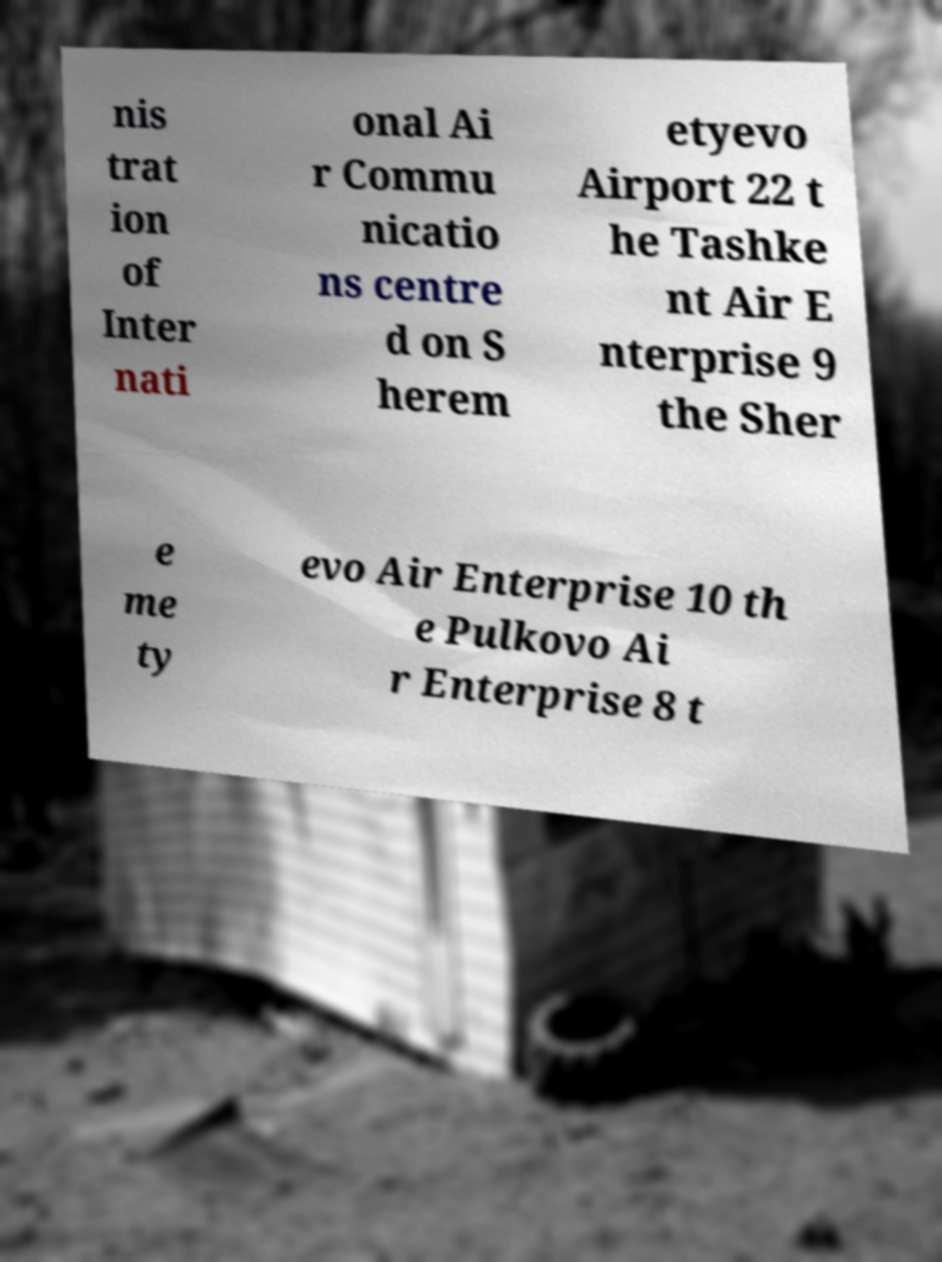Could you extract and type out the text from this image? nis trat ion of Inter nati onal Ai r Commu nicatio ns centre d on S herem etyevo Airport 22 t he Tashke nt Air E nterprise 9 the Sher e me ty evo Air Enterprise 10 th e Pulkovo Ai r Enterprise 8 t 